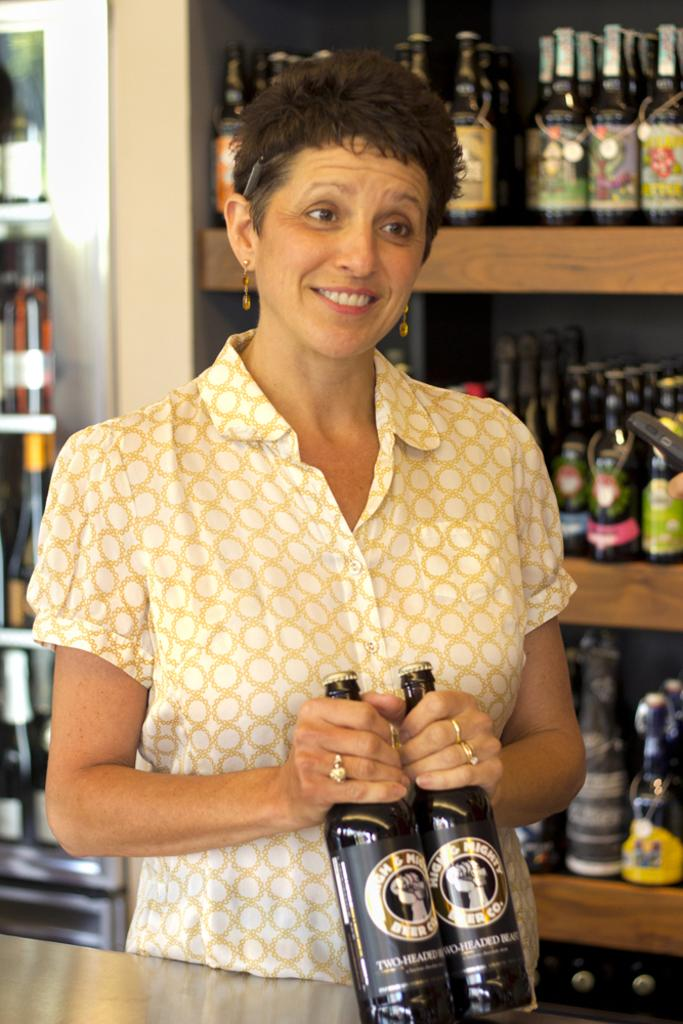Who is present in the image? There is a woman in the image. What is the woman doing in the image? The woman is standing in the image. What object is the woman holding in her hand? The woman is holding a wine bottle in her hand. What is in front of the woman in the image? There is a table in front of the woman. What can be seen at the back side of the image? There are many wine bottles in a rack. What type of bead is used to decorate the wine bottles in the image? There is no bead present on the wine bottles in the image; they are simply stored in a rack. How many buttons are visible on the woman's clothing in the image? There is no information about the woman's clothing or buttons in the image. 